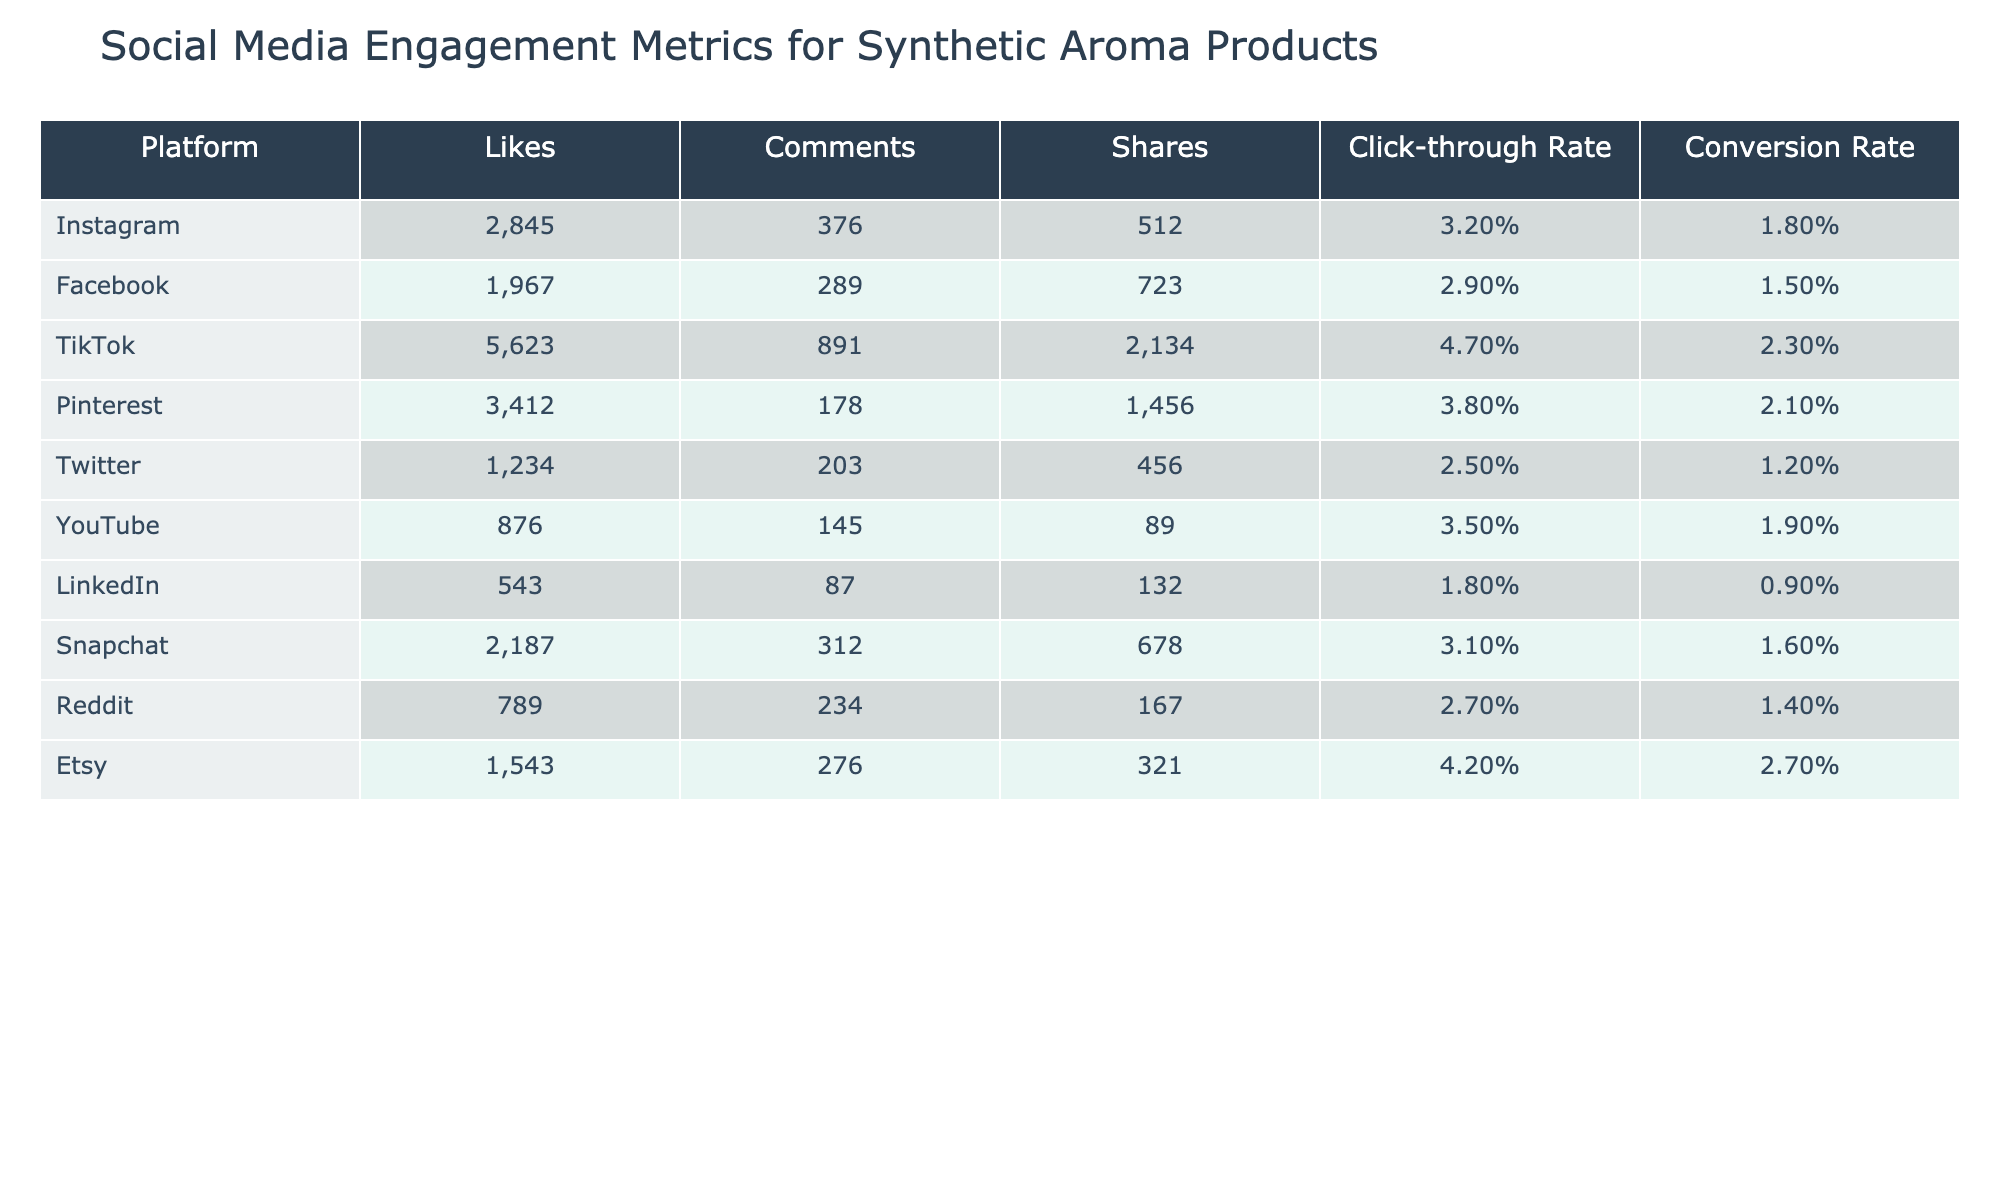What platform has the highest number of likes? By scanning the "Likes" column, TikTok has the highest value at 5623.
Answer: TikTok What is the average click-through rate across all platforms? Sum the click-through rates: (3.2 + 2.9 + 4.7 + 3.8 + 2.5 + 3.5 + 1.8 + 3.1 + 2.7 + 4.2) = 28.4 and divide by 10 (the number of platforms), resulting in an average of 2.84%.
Answer: 2.84% Which platform has the highest conversion rate? Checking the "Conversion Rate" column, TikTok has the highest value at 2.3%.
Answer: TikTok Is the click-through rate for Pinterest higher than that of Facebook? Pinterest's click-through rate is 3.8%, while Facebook's is 2.9%. Since 3.8% > 2.9%, the statement is true.
Answer: Yes What is the total number of shares from Instagram and Snapchat combined? The number of shares for Instagram is 512 and for Snapchat is 678. Adding these gives 512 + 678 = 1190.
Answer: 1190 What is the difference in the number of likes between TikTok and Twitter? TikTok has 5623 likes, and Twitter has 1234 likes. The difference is 5623 - 1234 = 4389.
Answer: 4389 Which platform has the lowest number of comments, and what is the value? By examining the "Comments" column, LinkedIn has the lowest value at 87.
Answer: LinkedIn, 87 Which platform has a higher conversion rate: Pinterest or Etsy? Pinterest has a conversion rate of 2.1%, while Etsy has 2.7%. Since 2.7% > 2.1%, Etsy has a higher conversion rate.
Answer: Etsy Calculate the total engagement (likes, comments, and shares) for TikTok. TikTok has 5623 likes, 891 comments, and 2134 shares. Summing these gives 5623 + 891 + 2134 = 8648.
Answer: 8648 Is it true that all platforms have a click-through rate above 2%? Reviewing the click-through rates, LinkedIn has a click-through rate of 1.8%, which is below 2%. Therefore, the statement is false.
Answer: No 